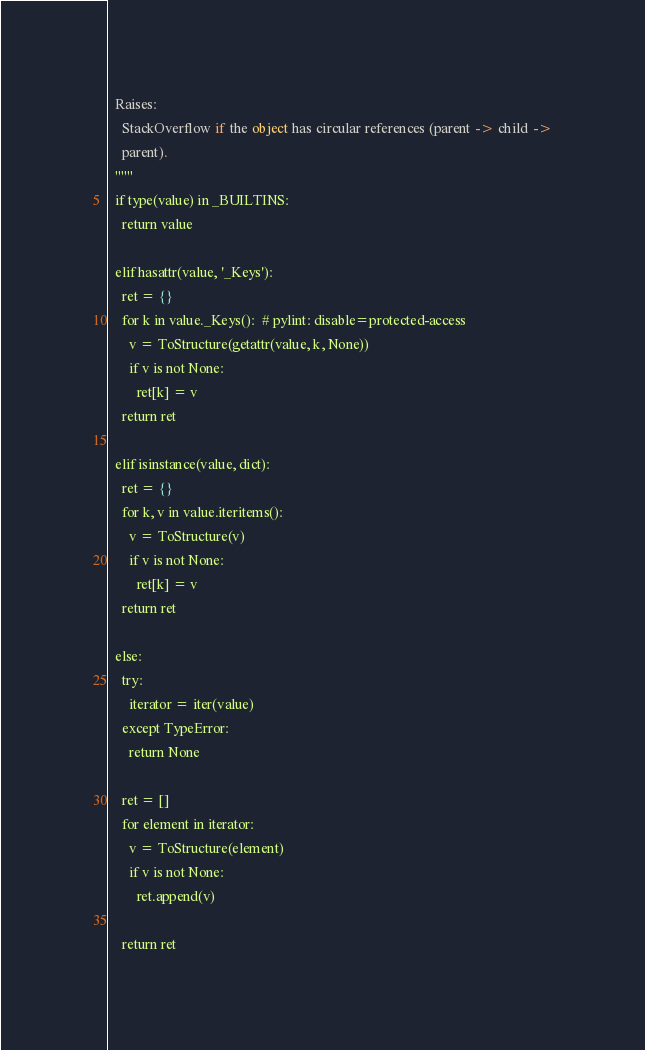Convert code to text. <code><loc_0><loc_0><loc_500><loc_500><_Python_>  Raises:
    StackOverflow if the object has circular references (parent -> child ->
    parent).
  """
  if type(value) in _BUILTINS:
    return value

  elif hasattr(value, '_Keys'):
    ret = {}
    for k in value._Keys():  # pylint: disable=protected-access
      v = ToStructure(getattr(value, k, None))
      if v is not None:
        ret[k] = v
    return ret

  elif isinstance(value, dict):
    ret = {}
    for k, v in value.iteritems():
      v = ToStructure(v)
      if v is not None:
        ret[k] = v
    return ret

  else:
    try:
      iterator = iter(value)
    except TypeError:
      return None

    ret = []
    for element in iterator:
      v = ToStructure(element)
      if v is not None:
        ret.append(v)

    return ret
</code> 